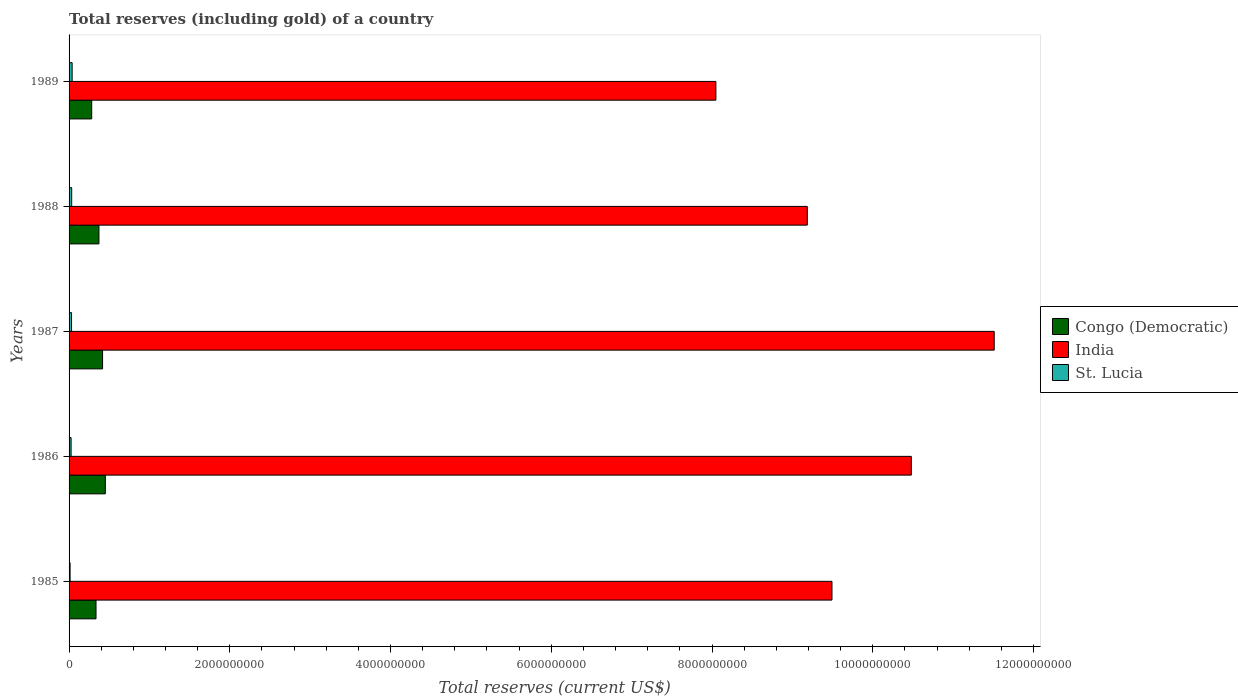How many different coloured bars are there?
Your answer should be compact. 3. How many groups of bars are there?
Your response must be concise. 5. Are the number of bars per tick equal to the number of legend labels?
Your answer should be very brief. Yes. How many bars are there on the 5th tick from the top?
Make the answer very short. 3. How many bars are there on the 4th tick from the bottom?
Keep it short and to the point. 3. In how many cases, is the number of bars for a given year not equal to the number of legend labels?
Keep it short and to the point. 0. What is the total reserves (including gold) in Congo (Democratic) in 1987?
Offer a very short reply. 4.17e+08. Across all years, what is the maximum total reserves (including gold) in India?
Ensure brevity in your answer.  1.15e+1. Across all years, what is the minimum total reserves (including gold) in Congo (Democratic)?
Your answer should be compact. 2.82e+08. What is the total total reserves (including gold) in Congo (Democratic) in the graph?
Provide a short and direct response. 1.86e+09. What is the difference between the total reserves (including gold) in St. Lucia in 1986 and that in 1988?
Provide a succinct answer. -7.54e+06. What is the difference between the total reserves (including gold) in St. Lucia in 1985 and the total reserves (including gold) in India in 1989?
Provide a short and direct response. -8.04e+09. What is the average total reserves (including gold) in Congo (Democratic) per year?
Provide a succinct answer. 3.71e+08. In the year 1987, what is the difference between the total reserves (including gold) in St. Lucia and total reserves (including gold) in India?
Keep it short and to the point. -1.15e+1. In how many years, is the total reserves (including gold) in Congo (Democratic) greater than 5600000000 US$?
Make the answer very short. 0. What is the ratio of the total reserves (including gold) in Congo (Democratic) in 1986 to that in 1989?
Your answer should be very brief. 1.6. What is the difference between the highest and the second highest total reserves (including gold) in Congo (Democratic)?
Your answer should be compact. 3.42e+07. What is the difference between the highest and the lowest total reserves (including gold) in Congo (Democratic)?
Keep it short and to the point. 1.69e+08. In how many years, is the total reserves (including gold) in India greater than the average total reserves (including gold) in India taken over all years?
Your answer should be compact. 2. Is the sum of the total reserves (including gold) in Congo (Democratic) in 1985 and 1986 greater than the maximum total reserves (including gold) in India across all years?
Keep it short and to the point. No. What does the 1st bar from the top in 1987 represents?
Your answer should be very brief. St. Lucia. What does the 3rd bar from the bottom in 1986 represents?
Make the answer very short. St. Lucia. How many bars are there?
Your response must be concise. 15. How many years are there in the graph?
Provide a succinct answer. 5. What is the difference between two consecutive major ticks on the X-axis?
Provide a short and direct response. 2.00e+09. Are the values on the major ticks of X-axis written in scientific E-notation?
Give a very brief answer. No. Does the graph contain any zero values?
Make the answer very short. No. Where does the legend appear in the graph?
Give a very brief answer. Center right. What is the title of the graph?
Your answer should be compact. Total reserves (including gold) of a country. What is the label or title of the X-axis?
Your answer should be very brief. Total reserves (current US$). What is the label or title of the Y-axis?
Ensure brevity in your answer.  Years. What is the Total reserves (current US$) in Congo (Democratic) in 1985?
Give a very brief answer. 3.35e+08. What is the Total reserves (current US$) in India in 1985?
Give a very brief answer. 9.49e+09. What is the Total reserves (current US$) in St. Lucia in 1985?
Provide a short and direct response. 1.26e+07. What is the Total reserves (current US$) of Congo (Democratic) in 1986?
Your answer should be very brief. 4.51e+08. What is the Total reserves (current US$) in India in 1986?
Ensure brevity in your answer.  1.05e+1. What is the Total reserves (current US$) in St. Lucia in 1986?
Offer a very short reply. 2.51e+07. What is the Total reserves (current US$) in Congo (Democratic) in 1987?
Your answer should be very brief. 4.17e+08. What is the Total reserves (current US$) of India in 1987?
Your response must be concise. 1.15e+1. What is the Total reserves (current US$) of St. Lucia in 1987?
Make the answer very short. 3.08e+07. What is the Total reserves (current US$) of Congo (Democratic) in 1988?
Provide a short and direct response. 3.72e+08. What is the Total reserves (current US$) in India in 1988?
Your answer should be compact. 9.19e+09. What is the Total reserves (current US$) of St. Lucia in 1988?
Ensure brevity in your answer.  3.26e+07. What is the Total reserves (current US$) in Congo (Democratic) in 1989?
Your answer should be very brief. 2.82e+08. What is the Total reserves (current US$) in India in 1989?
Offer a very short reply. 8.05e+09. What is the Total reserves (current US$) in St. Lucia in 1989?
Your response must be concise. 3.82e+07. Across all years, what is the maximum Total reserves (current US$) of Congo (Democratic)?
Your answer should be compact. 4.51e+08. Across all years, what is the maximum Total reserves (current US$) of India?
Offer a very short reply. 1.15e+1. Across all years, what is the maximum Total reserves (current US$) in St. Lucia?
Ensure brevity in your answer.  3.82e+07. Across all years, what is the minimum Total reserves (current US$) of Congo (Democratic)?
Offer a very short reply. 2.82e+08. Across all years, what is the minimum Total reserves (current US$) of India?
Keep it short and to the point. 8.05e+09. Across all years, what is the minimum Total reserves (current US$) of St. Lucia?
Ensure brevity in your answer.  1.26e+07. What is the total Total reserves (current US$) of Congo (Democratic) in the graph?
Your answer should be very brief. 1.86e+09. What is the total Total reserves (current US$) of India in the graph?
Keep it short and to the point. 4.87e+1. What is the total Total reserves (current US$) of St. Lucia in the graph?
Provide a short and direct response. 1.39e+08. What is the difference between the Total reserves (current US$) of Congo (Democratic) in 1985 and that in 1986?
Keep it short and to the point. -1.16e+08. What is the difference between the Total reserves (current US$) of India in 1985 and that in 1986?
Offer a terse response. -9.87e+08. What is the difference between the Total reserves (current US$) of St. Lucia in 1985 and that in 1986?
Your response must be concise. -1.25e+07. What is the difference between the Total reserves (current US$) in Congo (Democratic) in 1985 and that in 1987?
Your answer should be very brief. -8.18e+07. What is the difference between the Total reserves (current US$) in India in 1985 and that in 1987?
Provide a short and direct response. -2.02e+09. What is the difference between the Total reserves (current US$) of St. Lucia in 1985 and that in 1987?
Your response must be concise. -1.82e+07. What is the difference between the Total reserves (current US$) of Congo (Democratic) in 1985 and that in 1988?
Your response must be concise. -3.63e+07. What is the difference between the Total reserves (current US$) in India in 1985 and that in 1988?
Ensure brevity in your answer.  3.07e+08. What is the difference between the Total reserves (current US$) in St. Lucia in 1985 and that in 1988?
Make the answer very short. -2.00e+07. What is the difference between the Total reserves (current US$) of Congo (Democratic) in 1985 and that in 1989?
Provide a succinct answer. 5.35e+07. What is the difference between the Total reserves (current US$) in India in 1985 and that in 1989?
Provide a succinct answer. 1.44e+09. What is the difference between the Total reserves (current US$) in St. Lucia in 1985 and that in 1989?
Your response must be concise. -2.56e+07. What is the difference between the Total reserves (current US$) in Congo (Democratic) in 1986 and that in 1987?
Keep it short and to the point. 3.42e+07. What is the difference between the Total reserves (current US$) in India in 1986 and that in 1987?
Give a very brief answer. -1.03e+09. What is the difference between the Total reserves (current US$) of St. Lucia in 1986 and that in 1987?
Your answer should be compact. -5.69e+06. What is the difference between the Total reserves (current US$) of Congo (Democratic) in 1986 and that in 1988?
Provide a short and direct response. 7.96e+07. What is the difference between the Total reserves (current US$) of India in 1986 and that in 1988?
Your response must be concise. 1.29e+09. What is the difference between the Total reserves (current US$) of St. Lucia in 1986 and that in 1988?
Ensure brevity in your answer.  -7.54e+06. What is the difference between the Total reserves (current US$) of Congo (Democratic) in 1986 and that in 1989?
Keep it short and to the point. 1.69e+08. What is the difference between the Total reserves (current US$) in India in 1986 and that in 1989?
Provide a succinct answer. 2.43e+09. What is the difference between the Total reserves (current US$) in St. Lucia in 1986 and that in 1989?
Offer a very short reply. -1.31e+07. What is the difference between the Total reserves (current US$) of Congo (Democratic) in 1987 and that in 1988?
Make the answer very short. 4.55e+07. What is the difference between the Total reserves (current US$) in India in 1987 and that in 1988?
Keep it short and to the point. 2.33e+09. What is the difference between the Total reserves (current US$) in St. Lucia in 1987 and that in 1988?
Make the answer very short. -1.85e+06. What is the difference between the Total reserves (current US$) of Congo (Democratic) in 1987 and that in 1989?
Give a very brief answer. 1.35e+08. What is the difference between the Total reserves (current US$) in India in 1987 and that in 1989?
Keep it short and to the point. 3.46e+09. What is the difference between the Total reserves (current US$) in St. Lucia in 1987 and that in 1989?
Your answer should be very brief. -7.41e+06. What is the difference between the Total reserves (current US$) of Congo (Democratic) in 1988 and that in 1989?
Offer a very short reply. 8.99e+07. What is the difference between the Total reserves (current US$) of India in 1988 and that in 1989?
Give a very brief answer. 1.14e+09. What is the difference between the Total reserves (current US$) of St. Lucia in 1988 and that in 1989?
Your answer should be compact. -5.56e+06. What is the difference between the Total reserves (current US$) in Congo (Democratic) in 1985 and the Total reserves (current US$) in India in 1986?
Provide a short and direct response. -1.01e+1. What is the difference between the Total reserves (current US$) of Congo (Democratic) in 1985 and the Total reserves (current US$) of St. Lucia in 1986?
Your answer should be compact. 3.10e+08. What is the difference between the Total reserves (current US$) in India in 1985 and the Total reserves (current US$) in St. Lucia in 1986?
Provide a short and direct response. 9.47e+09. What is the difference between the Total reserves (current US$) in Congo (Democratic) in 1985 and the Total reserves (current US$) in India in 1987?
Your answer should be very brief. -1.12e+1. What is the difference between the Total reserves (current US$) of Congo (Democratic) in 1985 and the Total reserves (current US$) of St. Lucia in 1987?
Keep it short and to the point. 3.04e+08. What is the difference between the Total reserves (current US$) in India in 1985 and the Total reserves (current US$) in St. Lucia in 1987?
Your answer should be very brief. 9.46e+09. What is the difference between the Total reserves (current US$) in Congo (Democratic) in 1985 and the Total reserves (current US$) in India in 1988?
Give a very brief answer. -8.85e+09. What is the difference between the Total reserves (current US$) in Congo (Democratic) in 1985 and the Total reserves (current US$) in St. Lucia in 1988?
Ensure brevity in your answer.  3.03e+08. What is the difference between the Total reserves (current US$) in India in 1985 and the Total reserves (current US$) in St. Lucia in 1988?
Ensure brevity in your answer.  9.46e+09. What is the difference between the Total reserves (current US$) in Congo (Democratic) in 1985 and the Total reserves (current US$) in India in 1989?
Provide a short and direct response. -7.71e+09. What is the difference between the Total reserves (current US$) in Congo (Democratic) in 1985 and the Total reserves (current US$) in St. Lucia in 1989?
Your answer should be very brief. 2.97e+08. What is the difference between the Total reserves (current US$) of India in 1985 and the Total reserves (current US$) of St. Lucia in 1989?
Ensure brevity in your answer.  9.45e+09. What is the difference between the Total reserves (current US$) in Congo (Democratic) in 1986 and the Total reserves (current US$) in India in 1987?
Your answer should be compact. -1.11e+1. What is the difference between the Total reserves (current US$) in Congo (Democratic) in 1986 and the Total reserves (current US$) in St. Lucia in 1987?
Your answer should be very brief. 4.20e+08. What is the difference between the Total reserves (current US$) in India in 1986 and the Total reserves (current US$) in St. Lucia in 1987?
Your answer should be very brief. 1.04e+1. What is the difference between the Total reserves (current US$) in Congo (Democratic) in 1986 and the Total reserves (current US$) in India in 1988?
Offer a very short reply. -8.73e+09. What is the difference between the Total reserves (current US$) of Congo (Democratic) in 1986 and the Total reserves (current US$) of St. Lucia in 1988?
Make the answer very short. 4.19e+08. What is the difference between the Total reserves (current US$) in India in 1986 and the Total reserves (current US$) in St. Lucia in 1988?
Give a very brief answer. 1.04e+1. What is the difference between the Total reserves (current US$) in Congo (Democratic) in 1986 and the Total reserves (current US$) in India in 1989?
Ensure brevity in your answer.  -7.60e+09. What is the difference between the Total reserves (current US$) of Congo (Democratic) in 1986 and the Total reserves (current US$) of St. Lucia in 1989?
Make the answer very short. 4.13e+08. What is the difference between the Total reserves (current US$) of India in 1986 and the Total reserves (current US$) of St. Lucia in 1989?
Give a very brief answer. 1.04e+1. What is the difference between the Total reserves (current US$) of Congo (Democratic) in 1987 and the Total reserves (current US$) of India in 1988?
Make the answer very short. -8.77e+09. What is the difference between the Total reserves (current US$) of Congo (Democratic) in 1987 and the Total reserves (current US$) of St. Lucia in 1988?
Your answer should be very brief. 3.84e+08. What is the difference between the Total reserves (current US$) of India in 1987 and the Total reserves (current US$) of St. Lucia in 1988?
Provide a short and direct response. 1.15e+1. What is the difference between the Total reserves (current US$) of Congo (Democratic) in 1987 and the Total reserves (current US$) of India in 1989?
Provide a succinct answer. -7.63e+09. What is the difference between the Total reserves (current US$) in Congo (Democratic) in 1987 and the Total reserves (current US$) in St. Lucia in 1989?
Provide a succinct answer. 3.79e+08. What is the difference between the Total reserves (current US$) of India in 1987 and the Total reserves (current US$) of St. Lucia in 1989?
Offer a very short reply. 1.15e+1. What is the difference between the Total reserves (current US$) in Congo (Democratic) in 1988 and the Total reserves (current US$) in India in 1989?
Your answer should be very brief. -7.68e+09. What is the difference between the Total reserves (current US$) of Congo (Democratic) in 1988 and the Total reserves (current US$) of St. Lucia in 1989?
Provide a short and direct response. 3.33e+08. What is the difference between the Total reserves (current US$) in India in 1988 and the Total reserves (current US$) in St. Lucia in 1989?
Provide a succinct answer. 9.15e+09. What is the average Total reserves (current US$) of Congo (Democratic) per year?
Keep it short and to the point. 3.71e+08. What is the average Total reserves (current US$) of India per year?
Keep it short and to the point. 9.74e+09. What is the average Total reserves (current US$) of St. Lucia per year?
Ensure brevity in your answer.  2.79e+07. In the year 1985, what is the difference between the Total reserves (current US$) of Congo (Democratic) and Total reserves (current US$) of India?
Your answer should be very brief. -9.16e+09. In the year 1985, what is the difference between the Total reserves (current US$) in Congo (Democratic) and Total reserves (current US$) in St. Lucia?
Offer a very short reply. 3.23e+08. In the year 1985, what is the difference between the Total reserves (current US$) of India and Total reserves (current US$) of St. Lucia?
Give a very brief answer. 9.48e+09. In the year 1986, what is the difference between the Total reserves (current US$) in Congo (Democratic) and Total reserves (current US$) in India?
Give a very brief answer. -1.00e+1. In the year 1986, what is the difference between the Total reserves (current US$) of Congo (Democratic) and Total reserves (current US$) of St. Lucia?
Ensure brevity in your answer.  4.26e+08. In the year 1986, what is the difference between the Total reserves (current US$) in India and Total reserves (current US$) in St. Lucia?
Make the answer very short. 1.05e+1. In the year 1987, what is the difference between the Total reserves (current US$) in Congo (Democratic) and Total reserves (current US$) in India?
Your response must be concise. -1.11e+1. In the year 1987, what is the difference between the Total reserves (current US$) in Congo (Democratic) and Total reserves (current US$) in St. Lucia?
Give a very brief answer. 3.86e+08. In the year 1987, what is the difference between the Total reserves (current US$) in India and Total reserves (current US$) in St. Lucia?
Make the answer very short. 1.15e+1. In the year 1988, what is the difference between the Total reserves (current US$) in Congo (Democratic) and Total reserves (current US$) in India?
Give a very brief answer. -8.81e+09. In the year 1988, what is the difference between the Total reserves (current US$) in Congo (Democratic) and Total reserves (current US$) in St. Lucia?
Ensure brevity in your answer.  3.39e+08. In the year 1988, what is the difference between the Total reserves (current US$) in India and Total reserves (current US$) in St. Lucia?
Make the answer very short. 9.15e+09. In the year 1989, what is the difference between the Total reserves (current US$) in Congo (Democratic) and Total reserves (current US$) in India?
Offer a terse response. -7.77e+09. In the year 1989, what is the difference between the Total reserves (current US$) in Congo (Democratic) and Total reserves (current US$) in St. Lucia?
Give a very brief answer. 2.43e+08. In the year 1989, what is the difference between the Total reserves (current US$) in India and Total reserves (current US$) in St. Lucia?
Provide a short and direct response. 8.01e+09. What is the ratio of the Total reserves (current US$) in Congo (Democratic) in 1985 to that in 1986?
Ensure brevity in your answer.  0.74. What is the ratio of the Total reserves (current US$) in India in 1985 to that in 1986?
Offer a very short reply. 0.91. What is the ratio of the Total reserves (current US$) in St. Lucia in 1985 to that in 1986?
Offer a very short reply. 0.5. What is the ratio of the Total reserves (current US$) in Congo (Democratic) in 1985 to that in 1987?
Offer a terse response. 0.8. What is the ratio of the Total reserves (current US$) in India in 1985 to that in 1987?
Ensure brevity in your answer.  0.82. What is the ratio of the Total reserves (current US$) of St. Lucia in 1985 to that in 1987?
Keep it short and to the point. 0.41. What is the ratio of the Total reserves (current US$) of Congo (Democratic) in 1985 to that in 1988?
Your answer should be very brief. 0.9. What is the ratio of the Total reserves (current US$) of India in 1985 to that in 1988?
Your response must be concise. 1.03. What is the ratio of the Total reserves (current US$) in St. Lucia in 1985 to that in 1988?
Your answer should be very brief. 0.39. What is the ratio of the Total reserves (current US$) in Congo (Democratic) in 1985 to that in 1989?
Provide a succinct answer. 1.19. What is the ratio of the Total reserves (current US$) of India in 1985 to that in 1989?
Your answer should be very brief. 1.18. What is the ratio of the Total reserves (current US$) of St. Lucia in 1985 to that in 1989?
Offer a very short reply. 0.33. What is the ratio of the Total reserves (current US$) of Congo (Democratic) in 1986 to that in 1987?
Provide a short and direct response. 1.08. What is the ratio of the Total reserves (current US$) in India in 1986 to that in 1987?
Provide a succinct answer. 0.91. What is the ratio of the Total reserves (current US$) of St. Lucia in 1986 to that in 1987?
Your answer should be compact. 0.82. What is the ratio of the Total reserves (current US$) in Congo (Democratic) in 1986 to that in 1988?
Your answer should be very brief. 1.21. What is the ratio of the Total reserves (current US$) in India in 1986 to that in 1988?
Offer a very short reply. 1.14. What is the ratio of the Total reserves (current US$) of St. Lucia in 1986 to that in 1988?
Ensure brevity in your answer.  0.77. What is the ratio of the Total reserves (current US$) of Congo (Democratic) in 1986 to that in 1989?
Your answer should be compact. 1.6. What is the ratio of the Total reserves (current US$) in India in 1986 to that in 1989?
Make the answer very short. 1.3. What is the ratio of the Total reserves (current US$) in St. Lucia in 1986 to that in 1989?
Provide a succinct answer. 0.66. What is the ratio of the Total reserves (current US$) of Congo (Democratic) in 1987 to that in 1988?
Ensure brevity in your answer.  1.12. What is the ratio of the Total reserves (current US$) in India in 1987 to that in 1988?
Ensure brevity in your answer.  1.25. What is the ratio of the Total reserves (current US$) in St. Lucia in 1987 to that in 1988?
Offer a very short reply. 0.94. What is the ratio of the Total reserves (current US$) in Congo (Democratic) in 1987 to that in 1989?
Make the answer very short. 1.48. What is the ratio of the Total reserves (current US$) of India in 1987 to that in 1989?
Offer a terse response. 1.43. What is the ratio of the Total reserves (current US$) in St. Lucia in 1987 to that in 1989?
Give a very brief answer. 0.81. What is the ratio of the Total reserves (current US$) of Congo (Democratic) in 1988 to that in 1989?
Make the answer very short. 1.32. What is the ratio of the Total reserves (current US$) in India in 1988 to that in 1989?
Offer a terse response. 1.14. What is the ratio of the Total reserves (current US$) of St. Lucia in 1988 to that in 1989?
Ensure brevity in your answer.  0.85. What is the difference between the highest and the second highest Total reserves (current US$) of Congo (Democratic)?
Offer a terse response. 3.42e+07. What is the difference between the highest and the second highest Total reserves (current US$) of India?
Your answer should be very brief. 1.03e+09. What is the difference between the highest and the second highest Total reserves (current US$) in St. Lucia?
Keep it short and to the point. 5.56e+06. What is the difference between the highest and the lowest Total reserves (current US$) in Congo (Democratic)?
Keep it short and to the point. 1.69e+08. What is the difference between the highest and the lowest Total reserves (current US$) in India?
Offer a terse response. 3.46e+09. What is the difference between the highest and the lowest Total reserves (current US$) of St. Lucia?
Provide a short and direct response. 2.56e+07. 